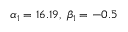<formula> <loc_0><loc_0><loc_500><loc_500>\alpha _ { 1 } = 1 6 . 1 9 , \, \beta _ { 1 } = - 0 . 5</formula> 